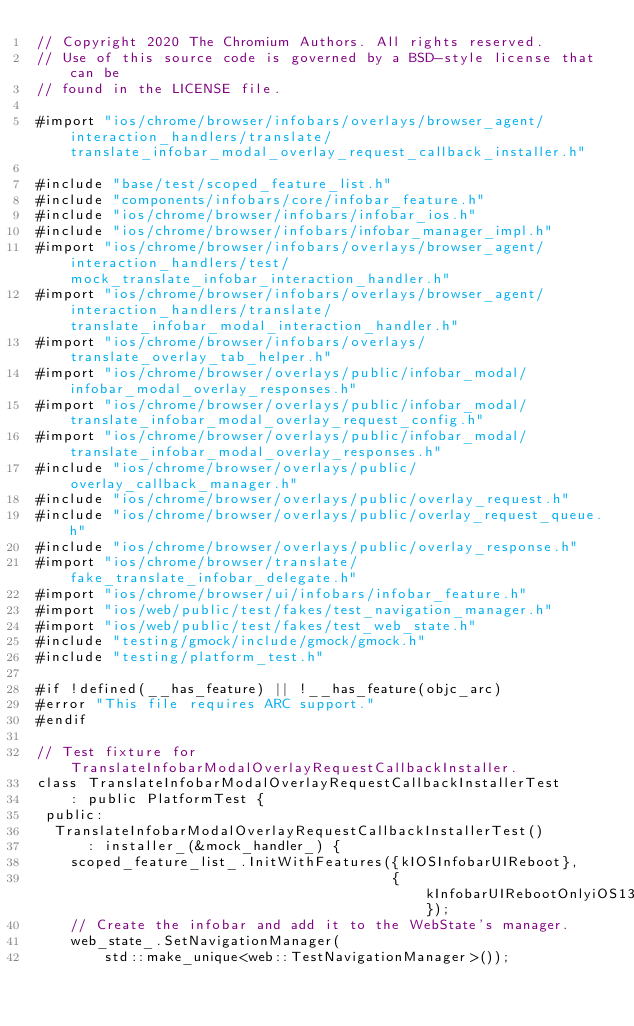Convert code to text. <code><loc_0><loc_0><loc_500><loc_500><_ObjectiveC_>// Copyright 2020 The Chromium Authors. All rights reserved.
// Use of this source code is governed by a BSD-style license that can be
// found in the LICENSE file.

#import "ios/chrome/browser/infobars/overlays/browser_agent/interaction_handlers/translate/translate_infobar_modal_overlay_request_callback_installer.h"

#include "base/test/scoped_feature_list.h"
#include "components/infobars/core/infobar_feature.h"
#include "ios/chrome/browser/infobars/infobar_ios.h"
#include "ios/chrome/browser/infobars/infobar_manager_impl.h"
#import "ios/chrome/browser/infobars/overlays/browser_agent/interaction_handlers/test/mock_translate_infobar_interaction_handler.h"
#import "ios/chrome/browser/infobars/overlays/browser_agent/interaction_handlers/translate/translate_infobar_modal_interaction_handler.h"
#import "ios/chrome/browser/infobars/overlays/translate_overlay_tab_helper.h"
#import "ios/chrome/browser/overlays/public/infobar_modal/infobar_modal_overlay_responses.h"
#import "ios/chrome/browser/overlays/public/infobar_modal/translate_infobar_modal_overlay_request_config.h"
#import "ios/chrome/browser/overlays/public/infobar_modal/translate_infobar_modal_overlay_responses.h"
#include "ios/chrome/browser/overlays/public/overlay_callback_manager.h"
#include "ios/chrome/browser/overlays/public/overlay_request.h"
#include "ios/chrome/browser/overlays/public/overlay_request_queue.h"
#include "ios/chrome/browser/overlays/public/overlay_response.h"
#import "ios/chrome/browser/translate/fake_translate_infobar_delegate.h"
#import "ios/chrome/browser/ui/infobars/infobar_feature.h"
#import "ios/web/public/test/fakes/test_navigation_manager.h"
#import "ios/web/public/test/fakes/test_web_state.h"
#include "testing/gmock/include/gmock/gmock.h"
#include "testing/platform_test.h"

#if !defined(__has_feature) || !__has_feature(objc_arc)
#error "This file requires ARC support."
#endif

// Test fixture for TranslateInfobarModalOverlayRequestCallbackInstaller.
class TranslateInfobarModalOverlayRequestCallbackInstallerTest
    : public PlatformTest {
 public:
  TranslateInfobarModalOverlayRequestCallbackInstallerTest()
      : installer_(&mock_handler_) {
    scoped_feature_list_.InitWithFeatures({kIOSInfobarUIReboot},
                                          {kInfobarUIRebootOnlyiOS13});
    // Create the infobar and add it to the WebState's manager.
    web_state_.SetNavigationManager(
        std::make_unique<web::TestNavigationManager>());</code> 